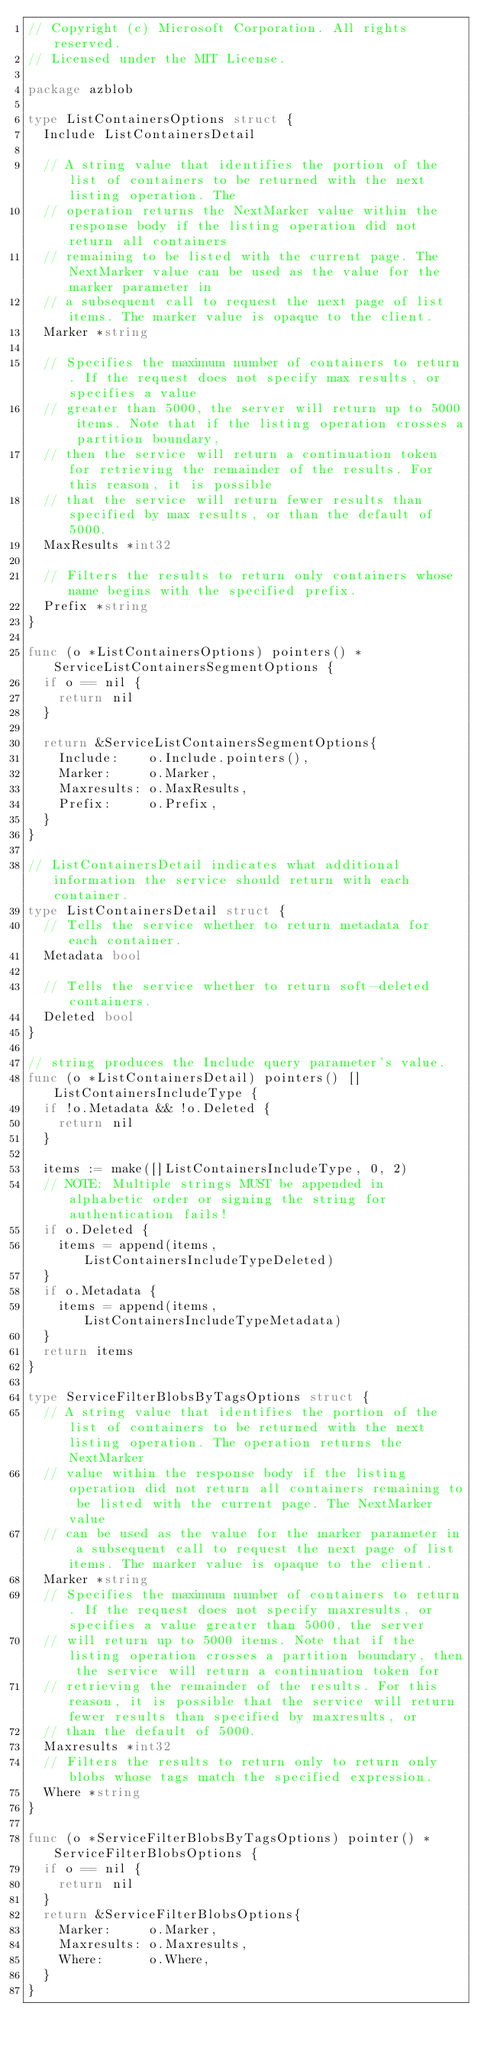Convert code to text. <code><loc_0><loc_0><loc_500><loc_500><_Go_>// Copyright (c) Microsoft Corporation. All rights reserved.
// Licensed under the MIT License.

package azblob

type ListContainersOptions struct {
	Include ListContainersDetail

	// A string value that identifies the portion of the list of containers to be returned with the next listing operation. The
	// operation returns the NextMarker value within the response body if the listing operation did not return all containers
	// remaining to be listed with the current page. The NextMarker value can be used as the value for the marker parameter in
	// a subsequent call to request the next page of list items. The marker value is opaque to the client.
	Marker *string

	// Specifies the maximum number of containers to return. If the request does not specify max results, or specifies a value
	// greater than 5000, the server will return up to 5000 items. Note that if the listing operation crosses a partition boundary,
	// then the service will return a continuation token for retrieving the remainder of the results. For this reason, it is possible
	// that the service will return fewer results than specified by max results, or than the default of 5000.
	MaxResults *int32

	// Filters the results to return only containers whose name begins with the specified prefix.
	Prefix *string
}

func (o *ListContainersOptions) pointers() *ServiceListContainersSegmentOptions {
	if o == nil {
		return nil
	}

	return &ServiceListContainersSegmentOptions{
		Include:    o.Include.pointers(),
		Marker:     o.Marker,
		Maxresults: o.MaxResults,
		Prefix:     o.Prefix,
	}
}

// ListContainersDetail indicates what additional information the service should return with each container.
type ListContainersDetail struct {
	// Tells the service whether to return metadata for each container.
	Metadata bool

	// Tells the service whether to return soft-deleted containers.
	Deleted bool
}

// string produces the Include query parameter's value.
func (o *ListContainersDetail) pointers() []ListContainersIncludeType {
	if !o.Metadata && !o.Deleted {
		return nil
	}

	items := make([]ListContainersIncludeType, 0, 2)
	// NOTE: Multiple strings MUST be appended in alphabetic order or signing the string for authentication fails!
	if o.Deleted {
		items = append(items, ListContainersIncludeTypeDeleted)
	}
	if o.Metadata {
		items = append(items, ListContainersIncludeTypeMetadata)
	}
	return items
}

type ServiceFilterBlobsByTagsOptions struct {
	// A string value that identifies the portion of the list of containers to be returned with the next listing operation. The operation returns the NextMarker
	// value within the response body if the listing operation did not return all containers remaining to be listed with the current page. The NextMarker value
	// can be used as the value for the marker parameter in a subsequent call to request the next page of list items. The marker value is opaque to the client.
	Marker *string
	// Specifies the maximum number of containers to return. If the request does not specify maxresults, or specifies a value greater than 5000, the server
	// will return up to 5000 items. Note that if the listing operation crosses a partition boundary, then the service will return a continuation token for
	// retrieving the remainder of the results. For this reason, it is possible that the service will return fewer results than specified by maxresults, or
	// than the default of 5000.
	Maxresults *int32
	// Filters the results to return only to return only blobs whose tags match the specified expression.
	Where *string
}

func (o *ServiceFilterBlobsByTagsOptions) pointer() *ServiceFilterBlobsOptions {
	if o == nil {
		return nil
	}
	return &ServiceFilterBlobsOptions{
		Marker:     o.Marker,
		Maxresults: o.Maxresults,
		Where:      o.Where,
	}
}
</code> 